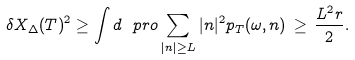<formula> <loc_0><loc_0><loc_500><loc_500>\delta X _ { \Delta } ( T ) ^ { 2 } \geq \int d \ p r o \sum _ { | n | \geq L } | n | ^ { 2 } p _ { T } ( \omega , n ) \, \geq \, \frac { L ^ { 2 } r } { 2 } .</formula> 